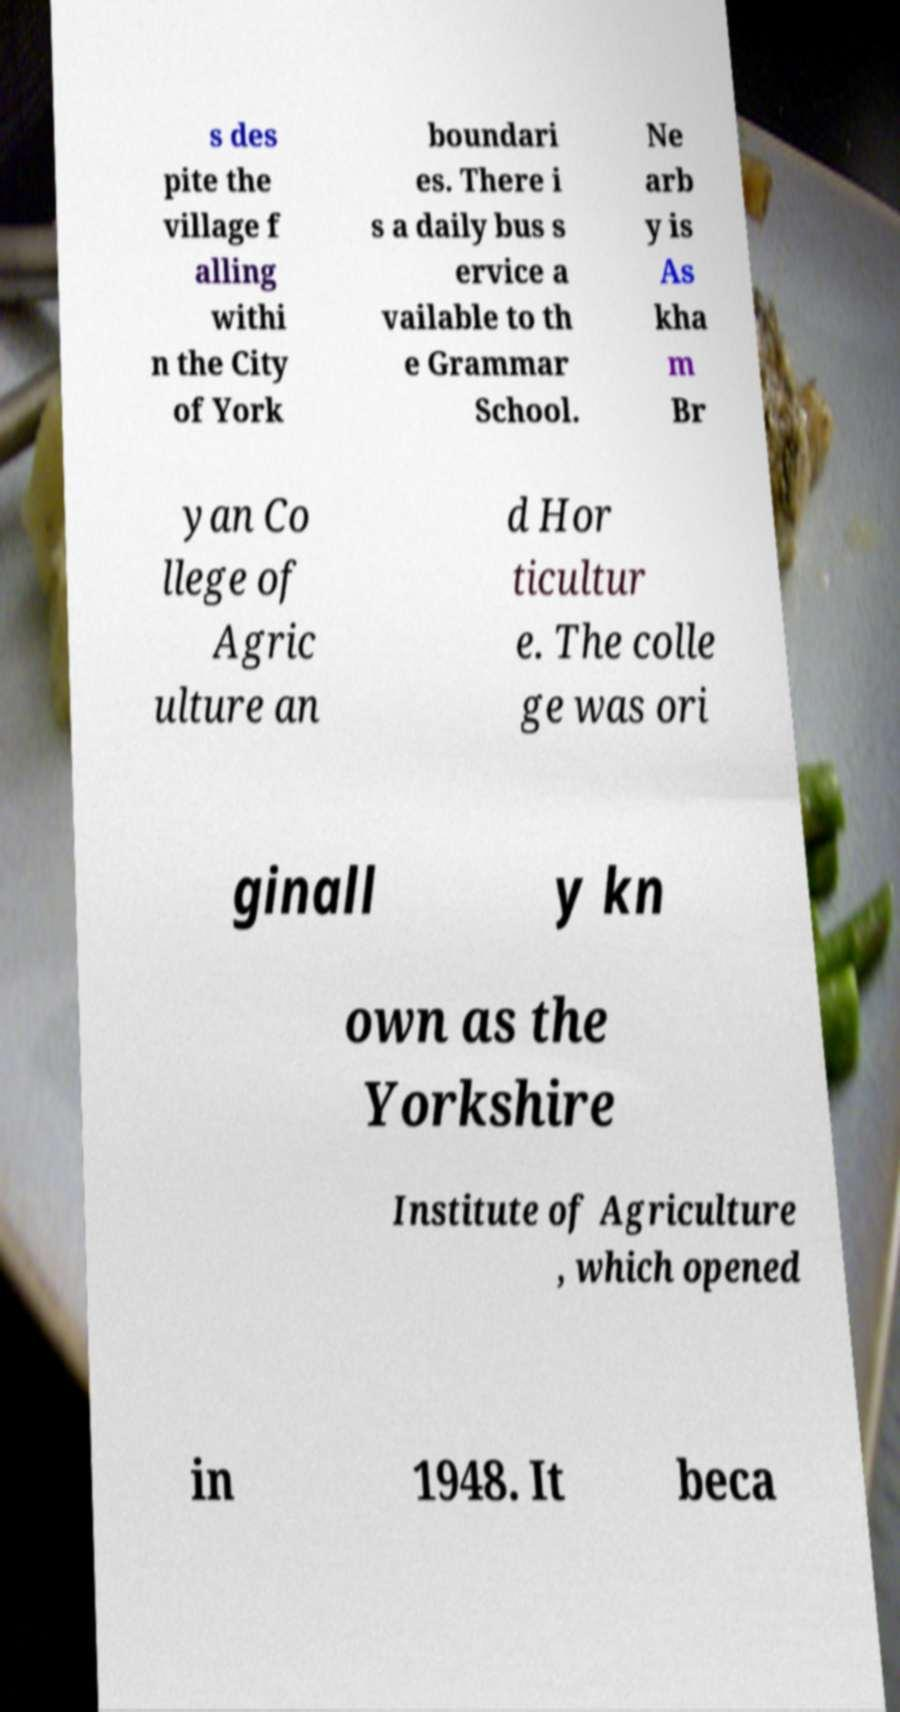Please read and relay the text visible in this image. What does it say? s des pite the village f alling withi n the City of York boundari es. There i s a daily bus s ervice a vailable to th e Grammar School. Ne arb y is As kha m Br yan Co llege of Agric ulture an d Hor ticultur e. The colle ge was ori ginall y kn own as the Yorkshire Institute of Agriculture , which opened in 1948. It beca 